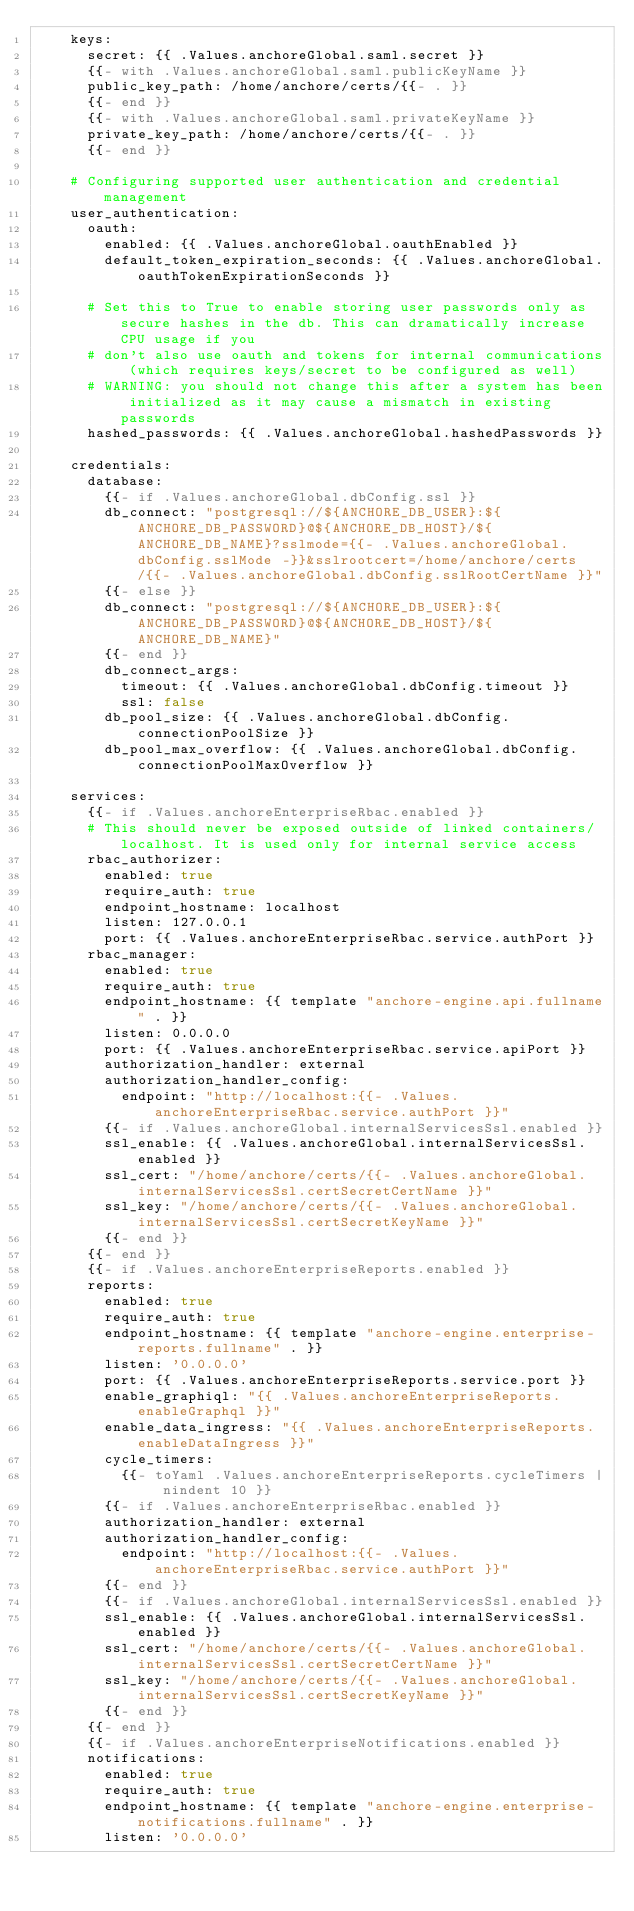<code> <loc_0><loc_0><loc_500><loc_500><_YAML_>    keys:
      secret: {{ .Values.anchoreGlobal.saml.secret }}
      {{- with .Values.anchoreGlobal.saml.publicKeyName }}
      public_key_path: /home/anchore/certs/{{- . }}
      {{- end }}
      {{- with .Values.anchoreGlobal.saml.privateKeyName }}
      private_key_path: /home/anchore/certs/{{- . }}
      {{- end }}

    # Configuring supported user authentication and credential management
    user_authentication:
      oauth:
        enabled: {{ .Values.anchoreGlobal.oauthEnabled }}
        default_token_expiration_seconds: {{ .Values.anchoreGlobal.oauthTokenExpirationSeconds }}

      # Set this to True to enable storing user passwords only as secure hashes in the db. This can dramatically increase CPU usage if you
      # don't also use oauth and tokens for internal communications (which requires keys/secret to be configured as well)
      # WARNING: you should not change this after a system has been initialized as it may cause a mismatch in existing passwords
      hashed_passwords: {{ .Values.anchoreGlobal.hashedPasswords }}

    credentials:
      database:
        {{- if .Values.anchoreGlobal.dbConfig.ssl }}
        db_connect: "postgresql://${ANCHORE_DB_USER}:${ANCHORE_DB_PASSWORD}@${ANCHORE_DB_HOST}/${ANCHORE_DB_NAME}?sslmode={{- .Values.anchoreGlobal.dbConfig.sslMode -}}&sslrootcert=/home/anchore/certs/{{- .Values.anchoreGlobal.dbConfig.sslRootCertName }}"
        {{- else }}
        db_connect: "postgresql://${ANCHORE_DB_USER}:${ANCHORE_DB_PASSWORD}@${ANCHORE_DB_HOST}/${ANCHORE_DB_NAME}"
        {{- end }}
        db_connect_args:
          timeout: {{ .Values.anchoreGlobal.dbConfig.timeout }}
          ssl: false
        db_pool_size: {{ .Values.anchoreGlobal.dbConfig.connectionPoolSize }}
        db_pool_max_overflow: {{ .Values.anchoreGlobal.dbConfig.connectionPoolMaxOverflow }}

    services:
      {{- if .Values.anchoreEnterpriseRbac.enabled }}
      # This should never be exposed outside of linked containers/localhost. It is used only for internal service access
      rbac_authorizer:
        enabled: true
        require_auth: true
        endpoint_hostname: localhost
        listen: 127.0.0.1
        port: {{ .Values.anchoreEnterpriseRbac.service.authPort }}
      rbac_manager:
        enabled: true
        require_auth: true
        endpoint_hostname: {{ template "anchore-engine.api.fullname" . }}
        listen: 0.0.0.0
        port: {{ .Values.anchoreEnterpriseRbac.service.apiPort }}
        authorization_handler: external
        authorization_handler_config:
          endpoint: "http://localhost:{{- .Values.anchoreEnterpriseRbac.service.authPort }}"
        {{- if .Values.anchoreGlobal.internalServicesSsl.enabled }}
        ssl_enable: {{ .Values.anchoreGlobal.internalServicesSsl.enabled }}
        ssl_cert: "/home/anchore/certs/{{- .Values.anchoreGlobal.internalServicesSsl.certSecretCertName }}"
        ssl_key: "/home/anchore/certs/{{- .Values.anchoreGlobal.internalServicesSsl.certSecretKeyName }}"
        {{- end }}
      {{- end }}
      {{- if .Values.anchoreEnterpriseReports.enabled }}
      reports:
        enabled: true
        require_auth: true
        endpoint_hostname: {{ template "anchore-engine.enterprise-reports.fullname" . }}
        listen: '0.0.0.0'
        port: {{ .Values.anchoreEnterpriseReports.service.port }}
        enable_graphiql: "{{ .Values.anchoreEnterpriseReports.enableGraphql }}"
        enable_data_ingress: "{{ .Values.anchoreEnterpriseReports.enableDataIngress }}"
        cycle_timers:
          {{- toYaml .Values.anchoreEnterpriseReports.cycleTimers | nindent 10 }}
        {{- if .Values.anchoreEnterpriseRbac.enabled }}
        authorization_handler: external
        authorization_handler_config:
          endpoint: "http://localhost:{{- .Values.anchoreEnterpriseRbac.service.authPort }}"
        {{- end }}
        {{- if .Values.anchoreGlobal.internalServicesSsl.enabled }}
        ssl_enable: {{ .Values.anchoreGlobal.internalServicesSsl.enabled }}
        ssl_cert: "/home/anchore/certs/{{- .Values.anchoreGlobal.internalServicesSsl.certSecretCertName }}"
        ssl_key: "/home/anchore/certs/{{- .Values.anchoreGlobal.internalServicesSsl.certSecretKeyName }}"
        {{- end }}
      {{- end }}
      {{- if .Values.anchoreEnterpriseNotifications.enabled }}
      notifications:
        enabled: true
        require_auth: true
        endpoint_hostname: {{ template "anchore-engine.enterprise-notifications.fullname" . }}
        listen: '0.0.0.0'</code> 